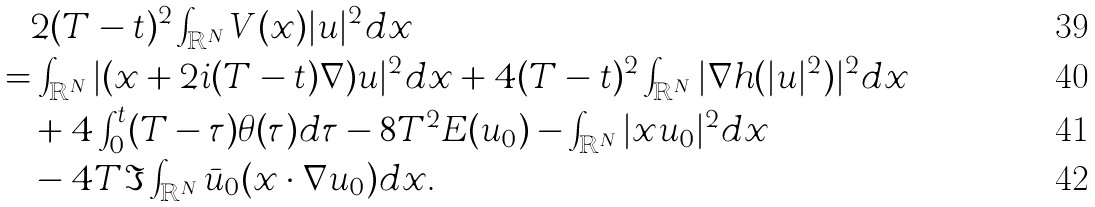<formula> <loc_0><loc_0><loc_500><loc_500>& \quad 2 ( T - t ) ^ { 2 } \int _ { \mathbb { R } ^ { N } } V ( x ) | u | ^ { 2 } d x \\ & = \int _ { \mathbb { R } ^ { N } } | ( x + 2 i ( T - t ) \nabla ) u | ^ { 2 } d x + 4 ( T - t ) ^ { 2 } \int _ { \mathbb { R } ^ { N } } | \nabla h ( | u | ^ { 2 } ) | ^ { 2 } d x \\ & \quad + 4 \int _ { 0 } ^ { t } ( T - \tau ) \theta ( \tau ) d \tau - 8 T ^ { 2 } E ( u _ { 0 } ) - \int _ { \mathbb { R } ^ { N } } | x u _ { 0 } | ^ { 2 } d x \\ & \quad - 4 T \Im \int _ { \mathbb { R } ^ { N } } \bar { u } _ { 0 } ( x \cdot \nabla u _ { 0 } ) d x .</formula> 